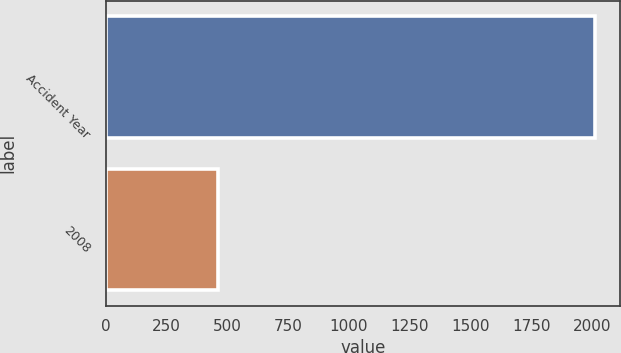Convert chart. <chart><loc_0><loc_0><loc_500><loc_500><bar_chart><fcel>Accident Year<fcel>2008<nl><fcel>2014<fcel>464<nl></chart> 